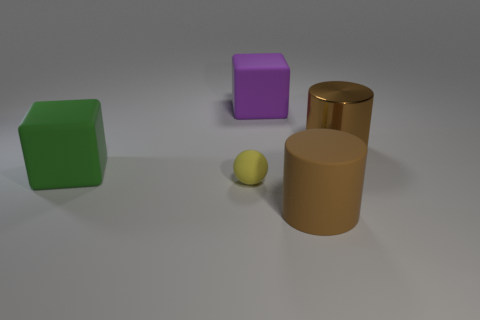Add 4 blue objects. How many objects exist? 9 Subtract all cylinders. How many objects are left? 3 Subtract all big green rubber cubes. Subtract all cyan shiny cubes. How many objects are left? 4 Add 4 cylinders. How many cylinders are left? 6 Add 1 red things. How many red things exist? 1 Subtract 0 red cubes. How many objects are left? 5 